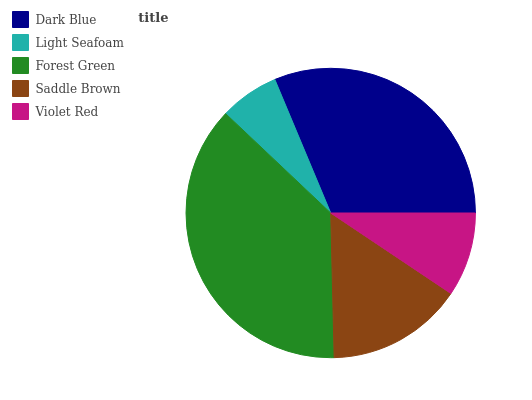Is Light Seafoam the minimum?
Answer yes or no. Yes. Is Forest Green the maximum?
Answer yes or no. Yes. Is Forest Green the minimum?
Answer yes or no. No. Is Light Seafoam the maximum?
Answer yes or no. No. Is Forest Green greater than Light Seafoam?
Answer yes or no. Yes. Is Light Seafoam less than Forest Green?
Answer yes or no. Yes. Is Light Seafoam greater than Forest Green?
Answer yes or no. No. Is Forest Green less than Light Seafoam?
Answer yes or no. No. Is Saddle Brown the high median?
Answer yes or no. Yes. Is Saddle Brown the low median?
Answer yes or no. Yes. Is Forest Green the high median?
Answer yes or no. No. Is Forest Green the low median?
Answer yes or no. No. 